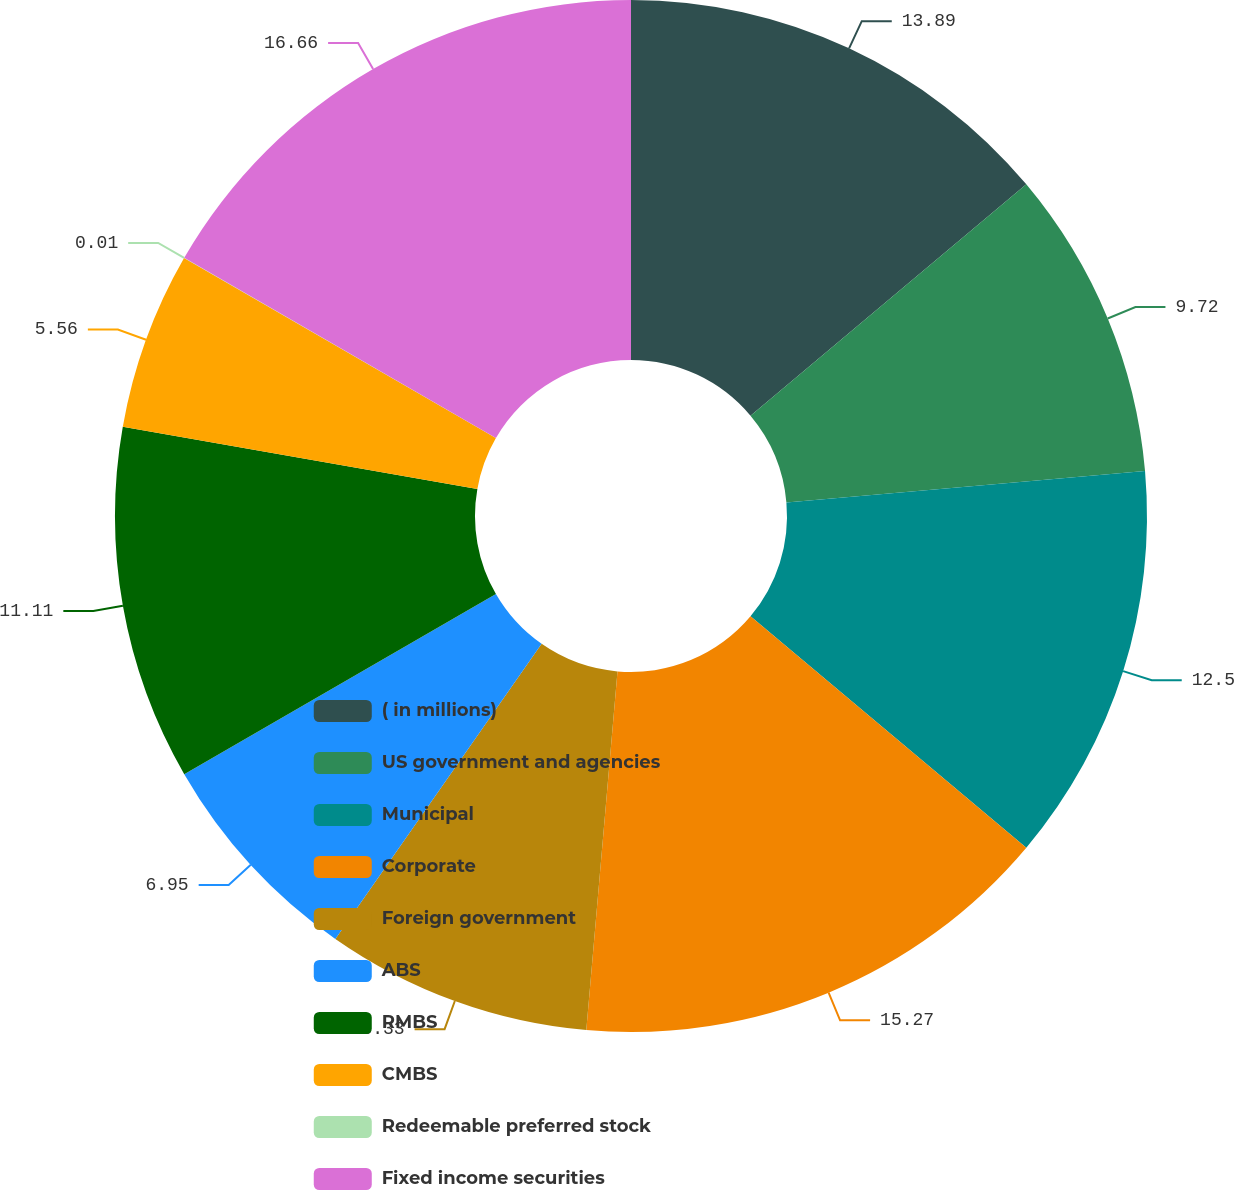<chart> <loc_0><loc_0><loc_500><loc_500><pie_chart><fcel>( in millions)<fcel>US government and agencies<fcel>Municipal<fcel>Corporate<fcel>Foreign government<fcel>ABS<fcel>RMBS<fcel>CMBS<fcel>Redeemable preferred stock<fcel>Fixed income securities<nl><fcel>13.89%<fcel>9.72%<fcel>12.5%<fcel>15.27%<fcel>8.33%<fcel>6.95%<fcel>11.11%<fcel>5.56%<fcel>0.01%<fcel>16.66%<nl></chart> 